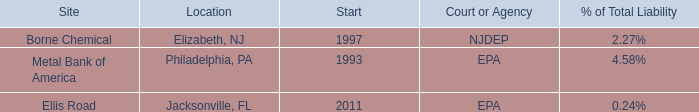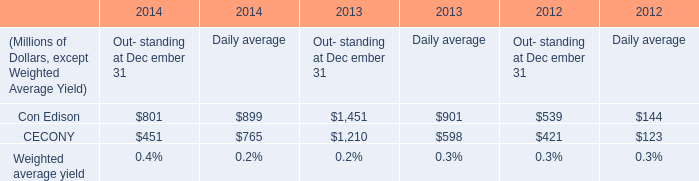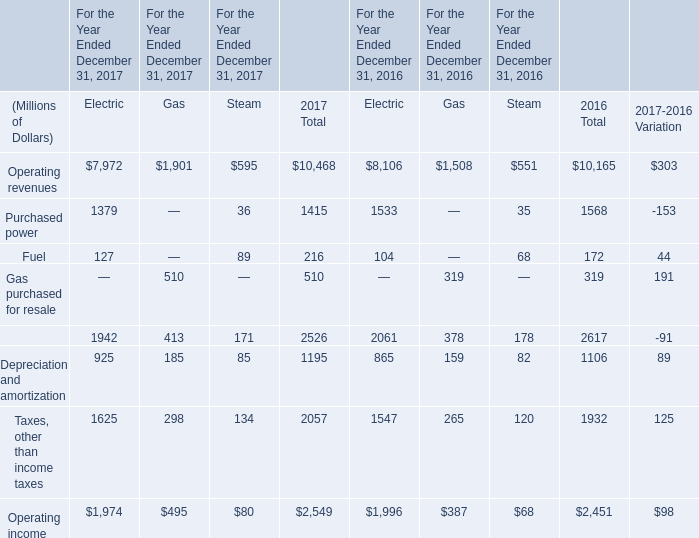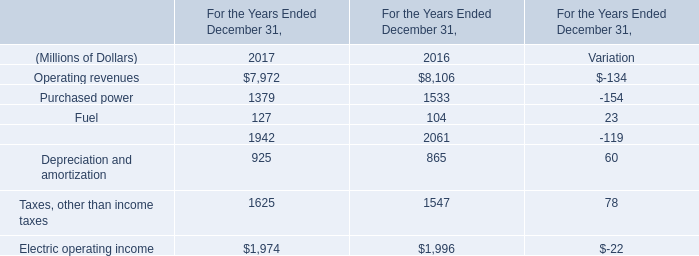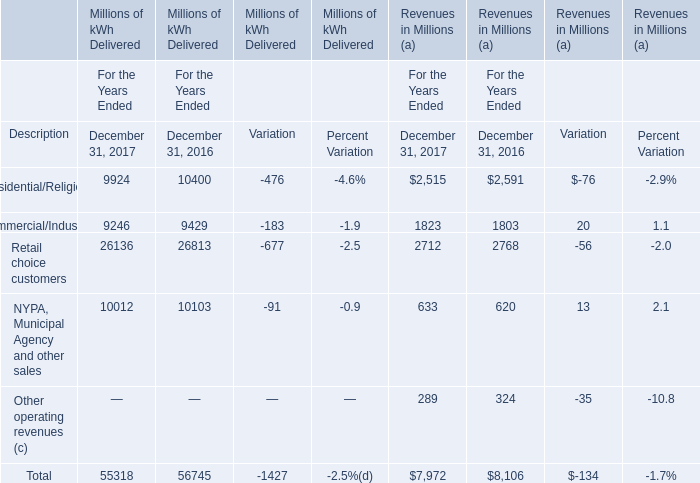In the year with largest amount of Fuel of Electric, what's the sum of Operating revenues and Purchased power of Electric? (in million) 
Computations: (7972 + 1379)
Answer: 9351.0. 